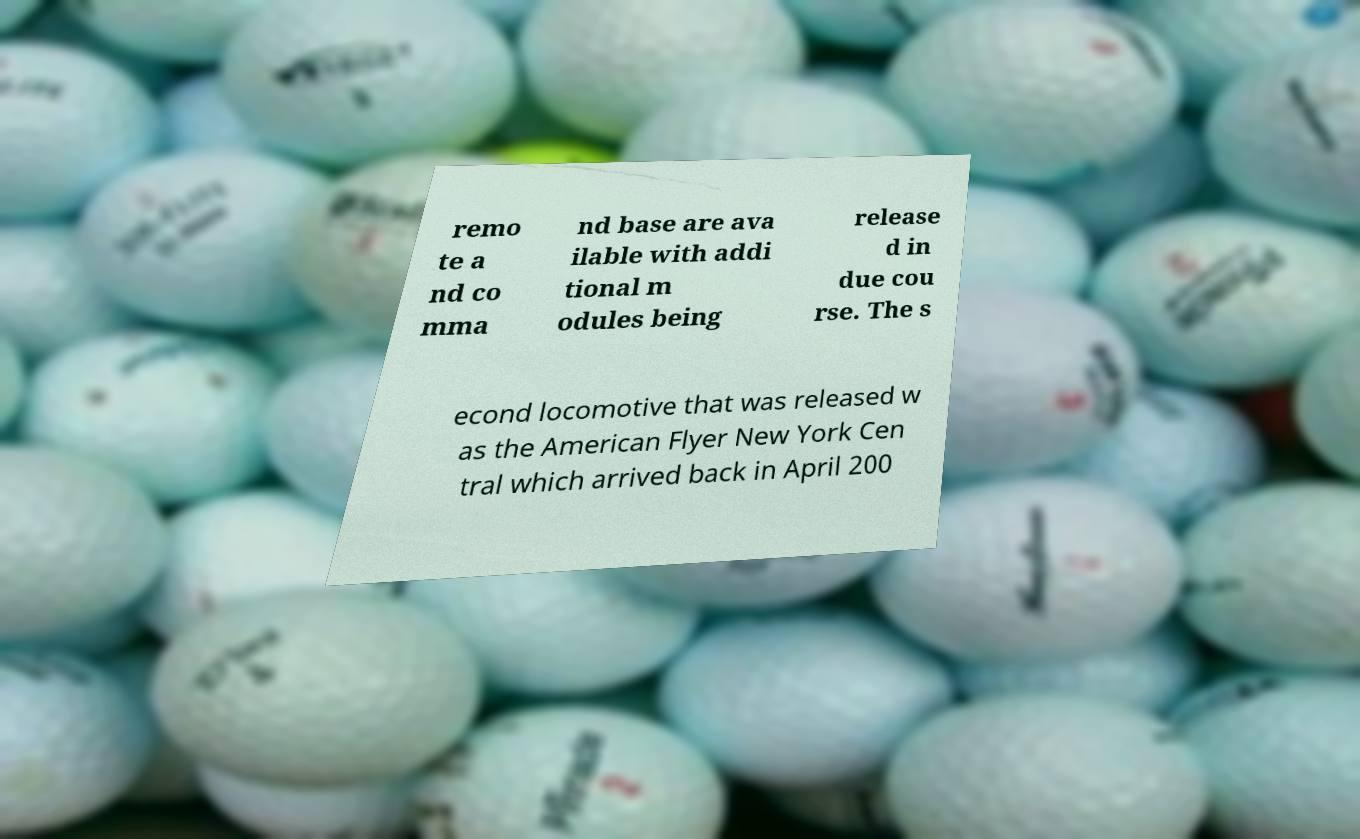Please read and relay the text visible in this image. What does it say? remo te a nd co mma nd base are ava ilable with addi tional m odules being release d in due cou rse. The s econd locomotive that was released w as the American Flyer New York Cen tral which arrived back in April 200 